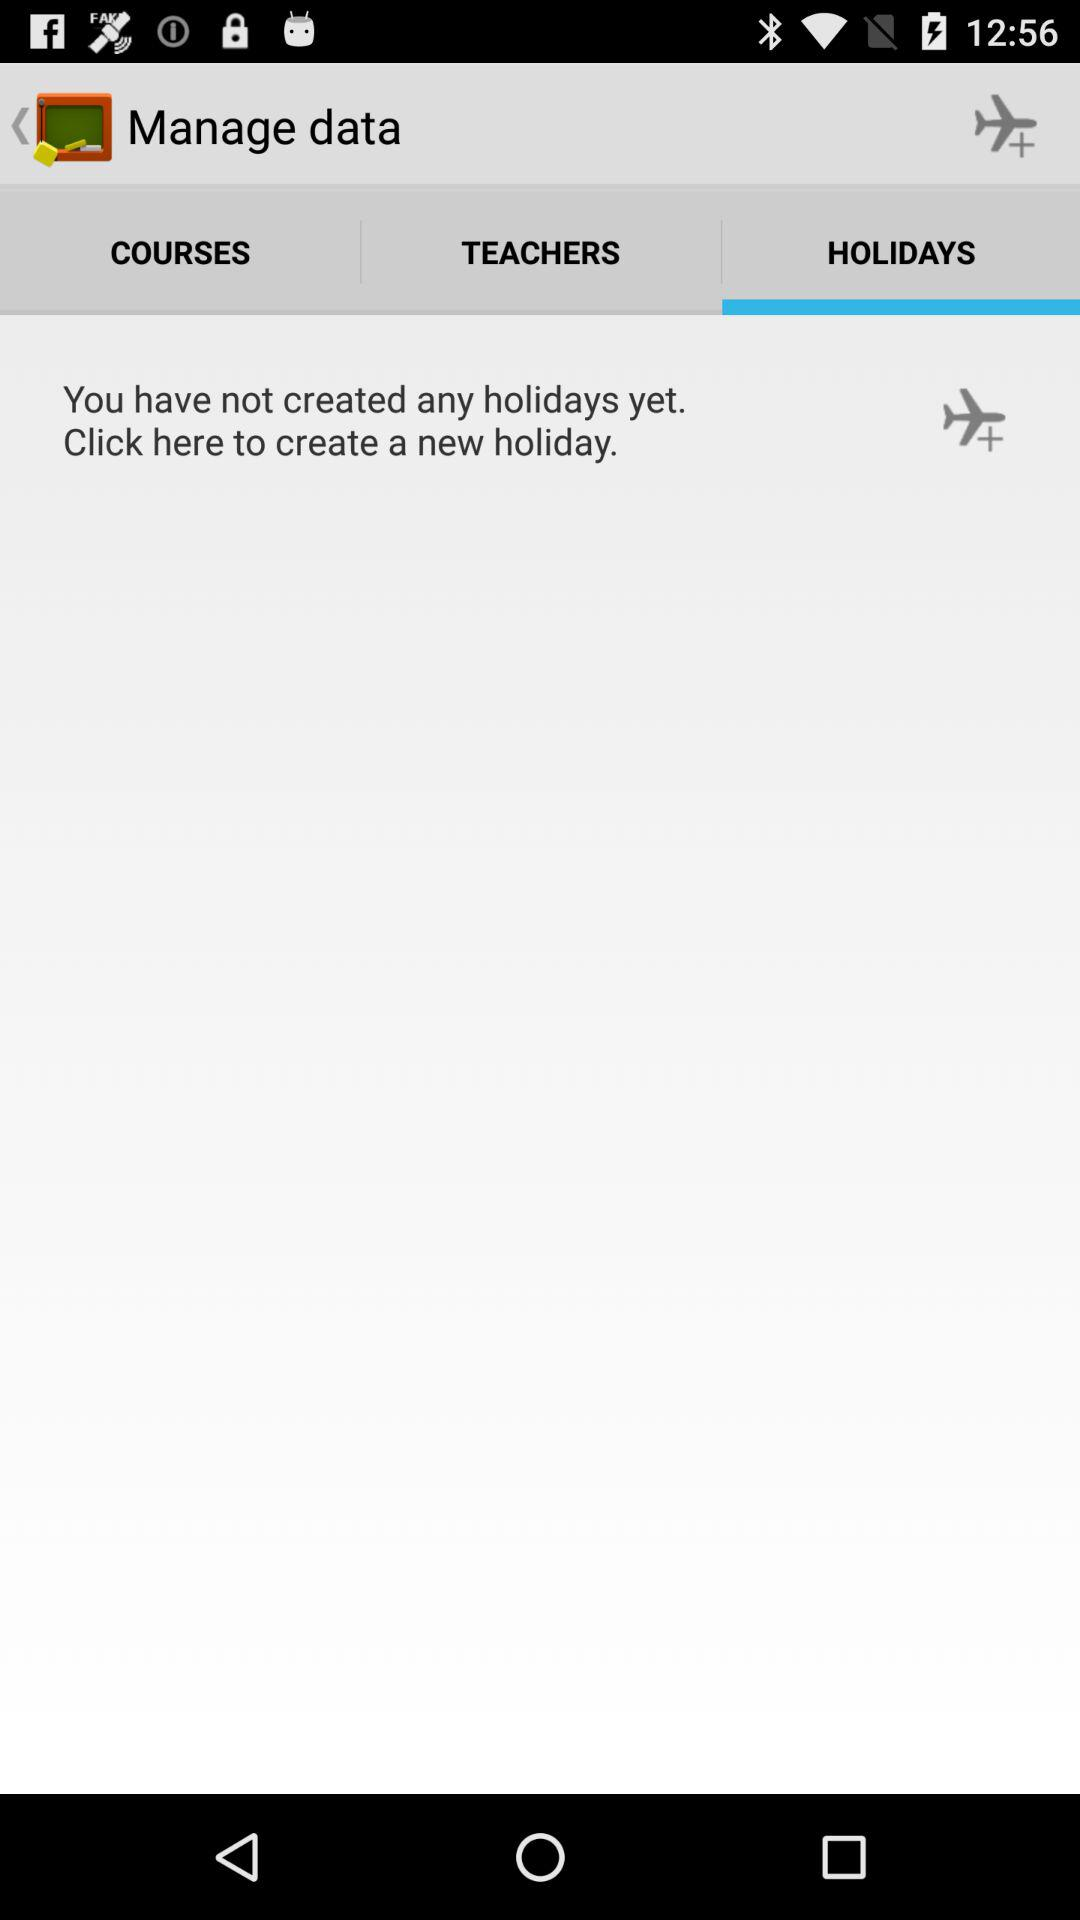Which tab is selected? The selected tab is "HOLIDAYS". 